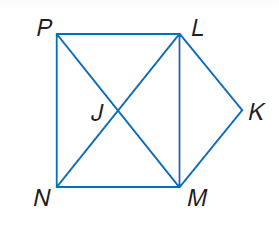Answer the mathemtical geometry problem and directly provide the correct option letter.
Question: Use rectangle L M N P, parallelogram L K M J to solve the problem. If m \angle M J N = 35, find m \angle M P N.
Choices: A: 17.5 B: 30 C: 35 D: 70 A 